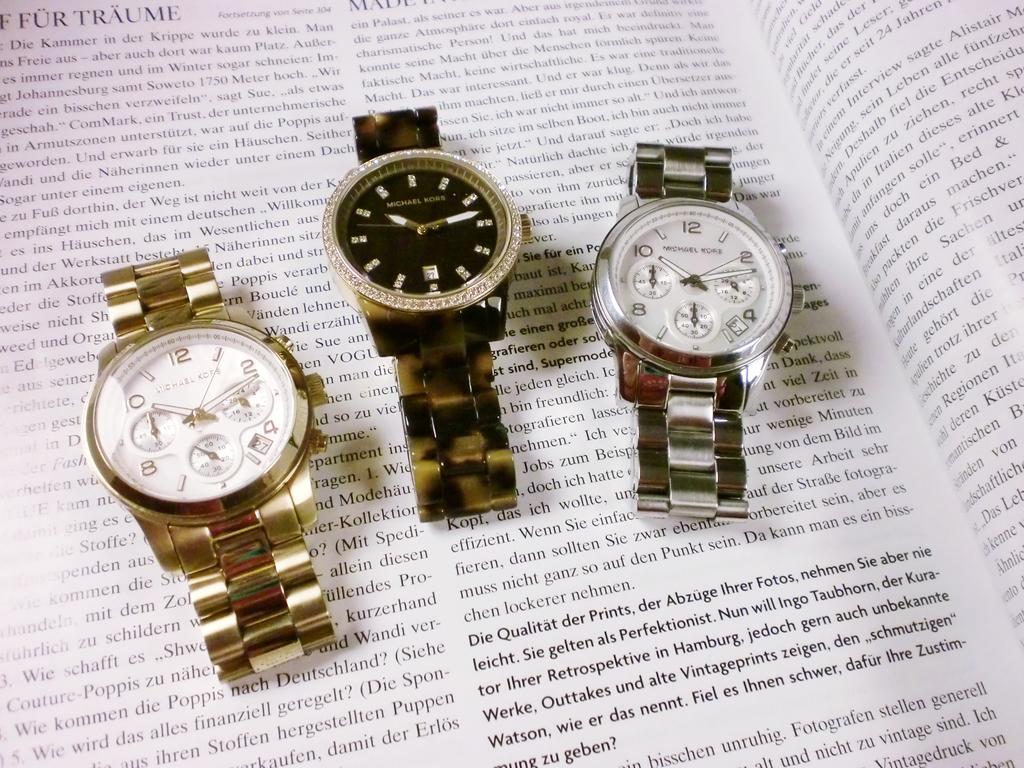Are those designer watches?
Provide a succinct answer. Yes. What time is on the watches?
Make the answer very short. 10:12. 